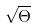<formula> <loc_0><loc_0><loc_500><loc_500>\sqrt { \Theta }</formula> 